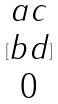<formula> <loc_0><loc_0><loc_500><loc_500>[ \begin{matrix} a c \\ b d \\ 0 \end{matrix} ]</formula> 